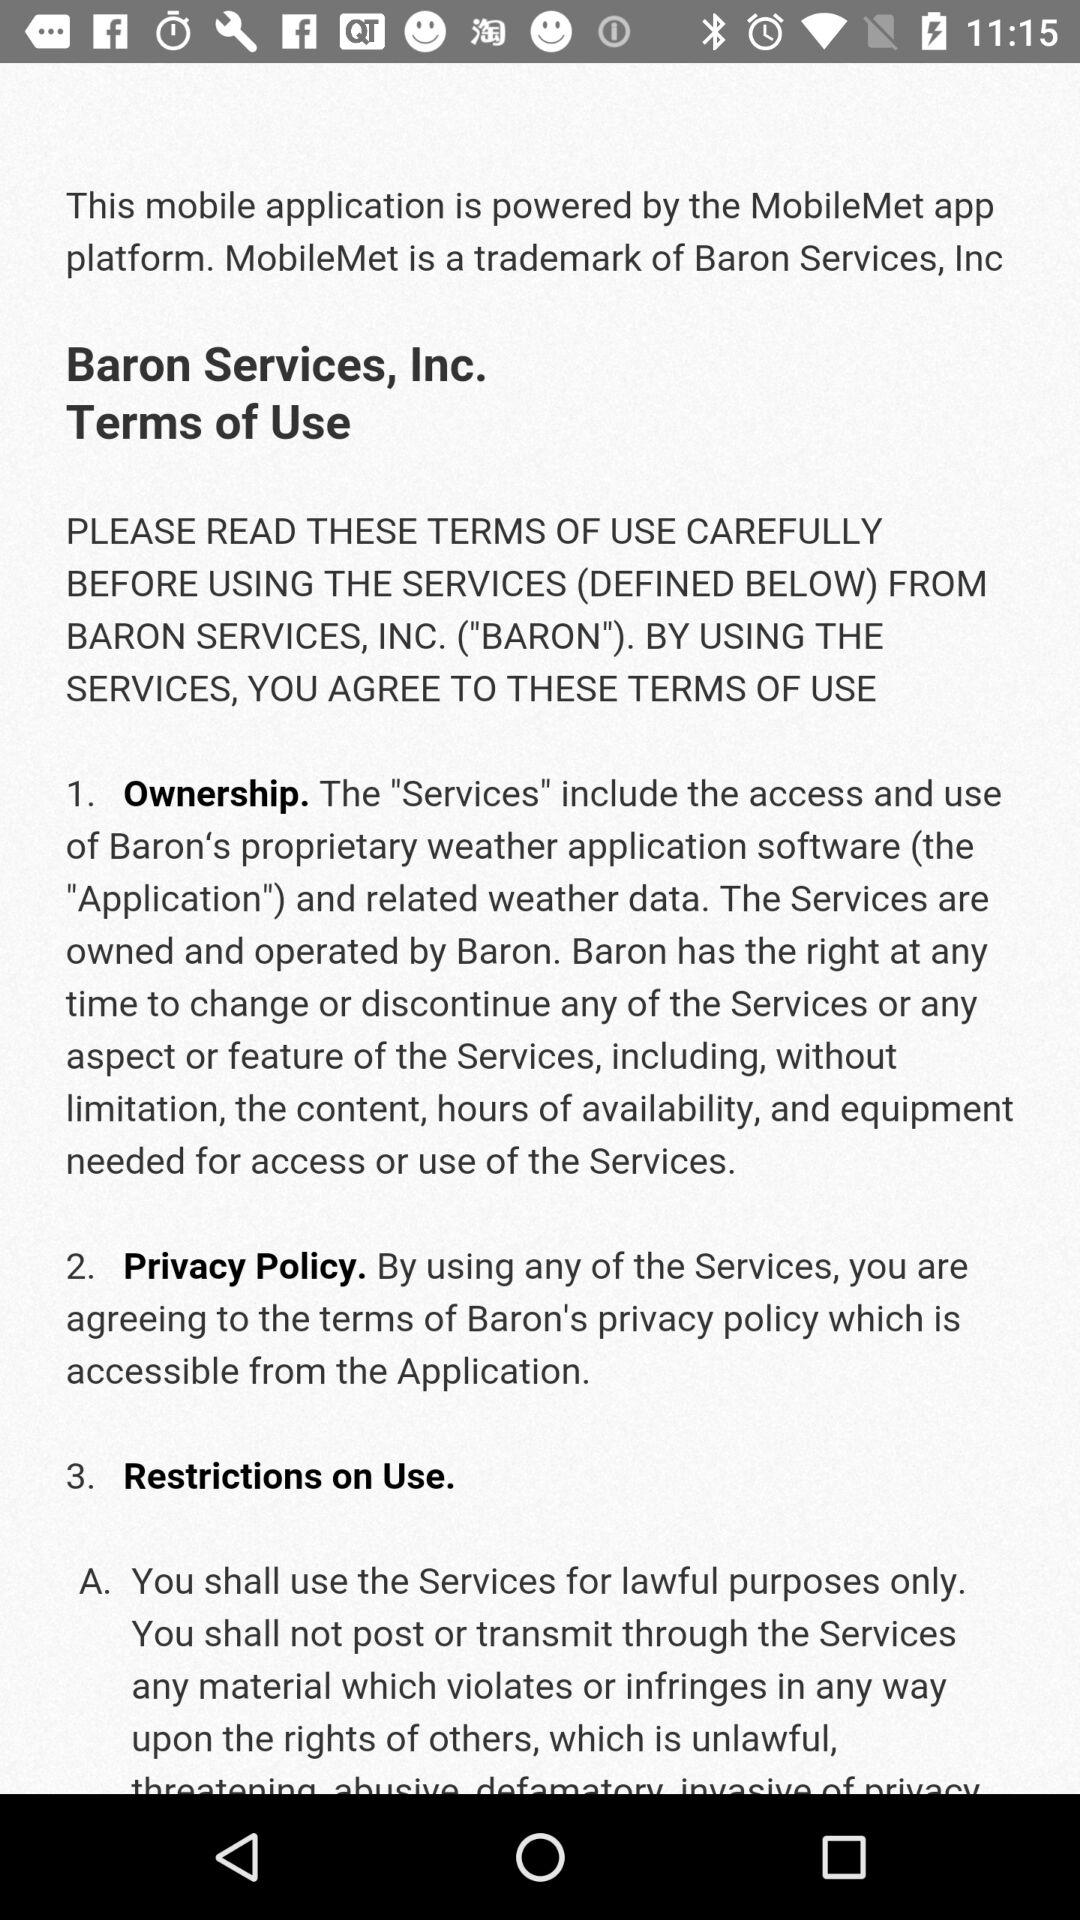What is a privacy policy? A privacy policy is "By using any of the Services, you are agreeing to the terms of Baron's privacy policy which is accessible from the Application". 